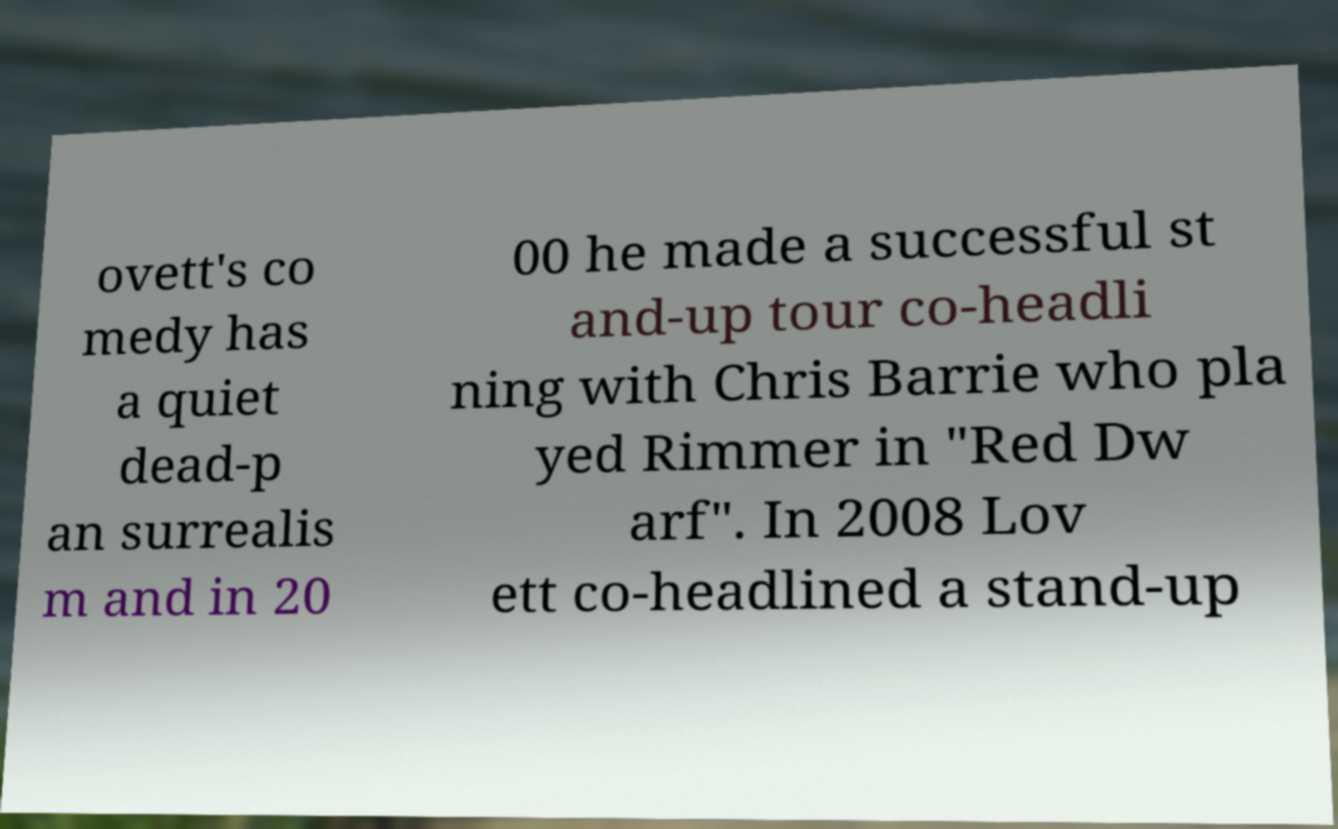Can you read and provide the text displayed in the image?This photo seems to have some interesting text. Can you extract and type it out for me? ovett's co medy has a quiet dead-p an surrealis m and in 20 00 he made a successful st and-up tour co-headli ning with Chris Barrie who pla yed Rimmer in "Red Dw arf". In 2008 Lov ett co-headlined a stand-up 